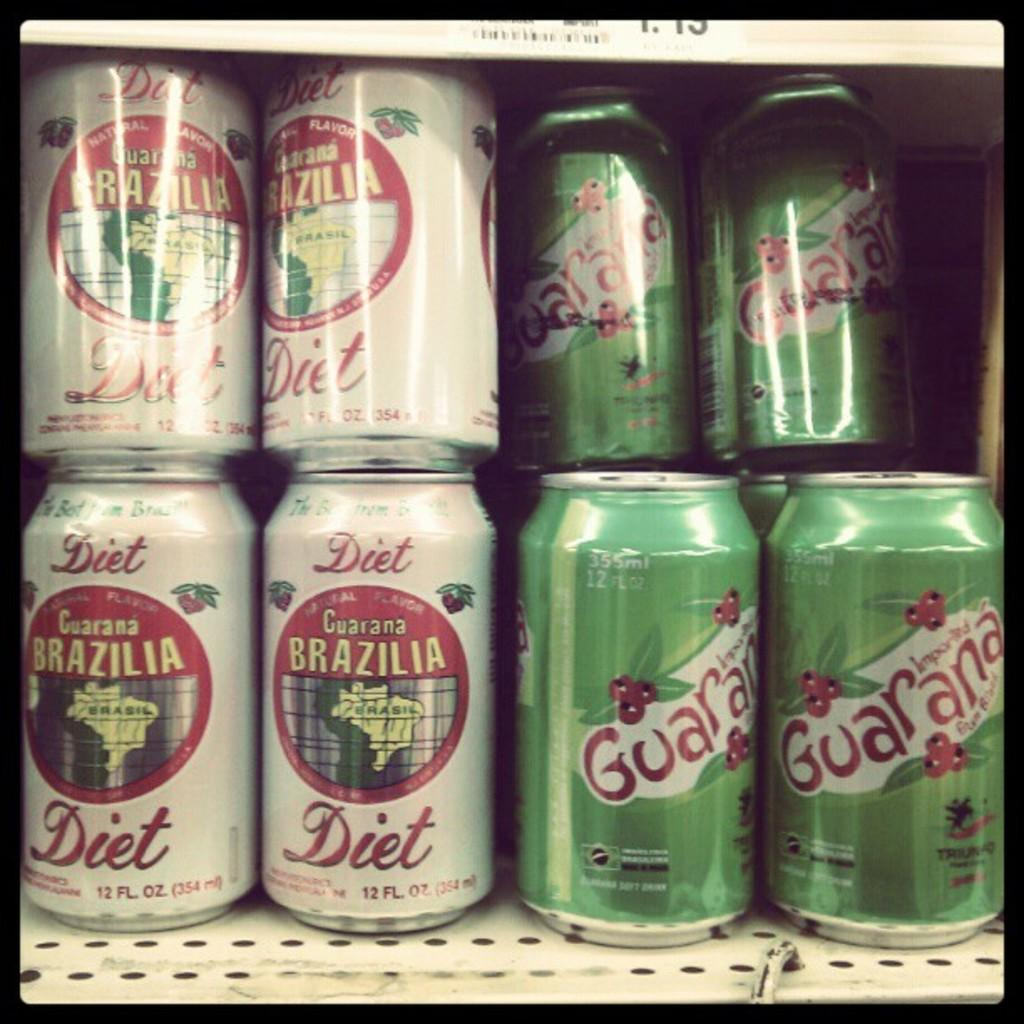<image>
Render a clear and concise summary of the photo. The green colored canned drink, "Guarana," sits next to a white colored canned drink. 